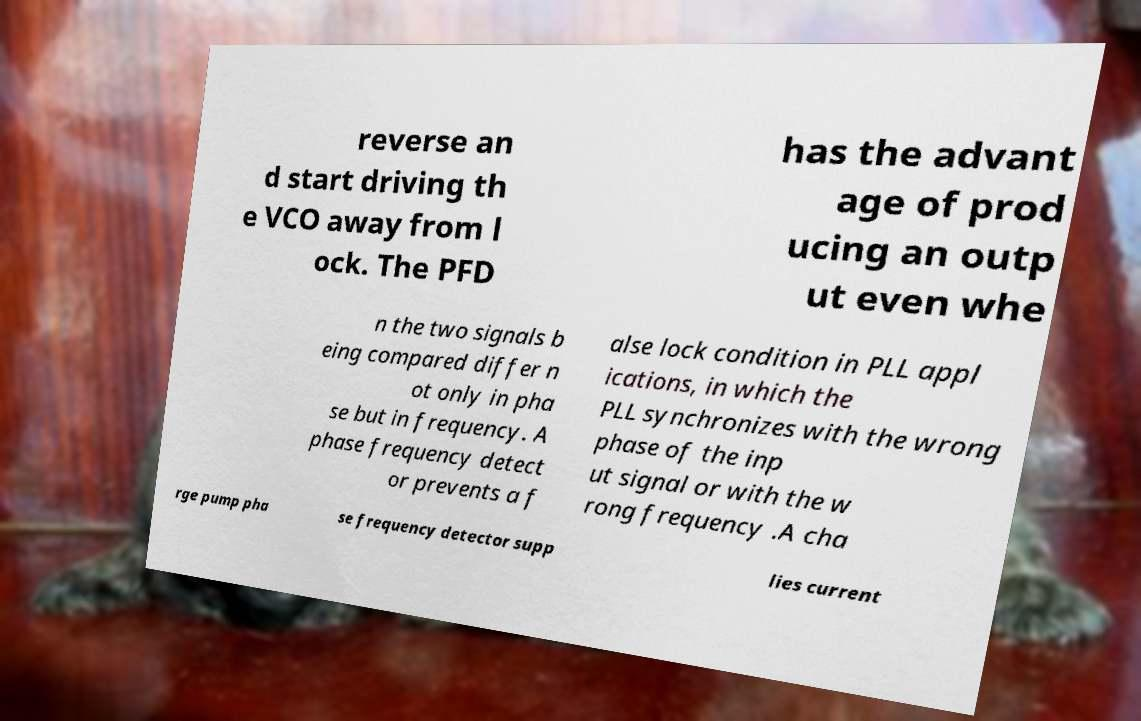For documentation purposes, I need the text within this image transcribed. Could you provide that? reverse an d start driving th e VCO away from l ock. The PFD has the advant age of prod ucing an outp ut even whe n the two signals b eing compared differ n ot only in pha se but in frequency. A phase frequency detect or prevents a f alse lock condition in PLL appl ications, in which the PLL synchronizes with the wrong phase of the inp ut signal or with the w rong frequency .A cha rge pump pha se frequency detector supp lies current 